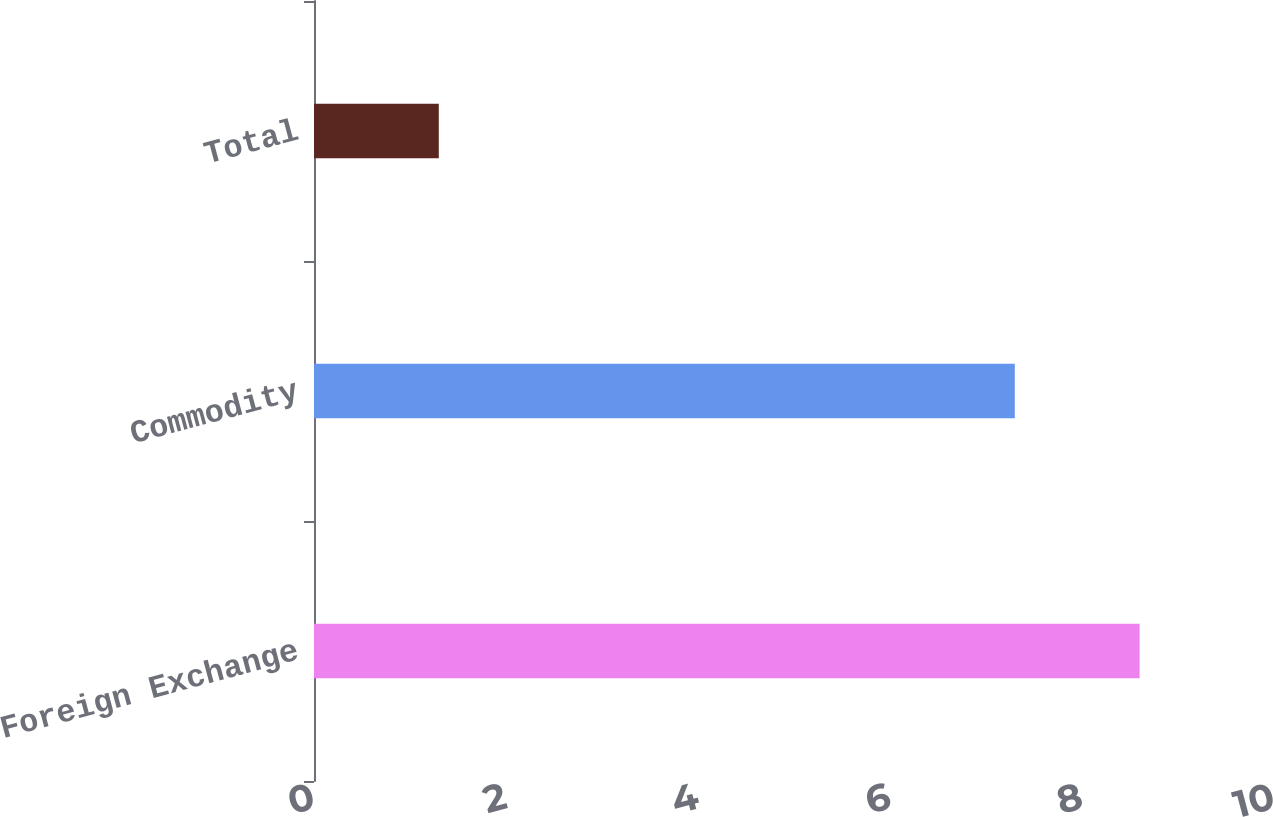<chart> <loc_0><loc_0><loc_500><loc_500><bar_chart><fcel>Foreign Exchange<fcel>Commodity<fcel>Total<nl><fcel>8.6<fcel>7.3<fcel>1.3<nl></chart> 